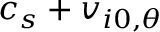<formula> <loc_0><loc_0><loc_500><loc_500>c _ { s } + v _ { i 0 , \theta }</formula> 